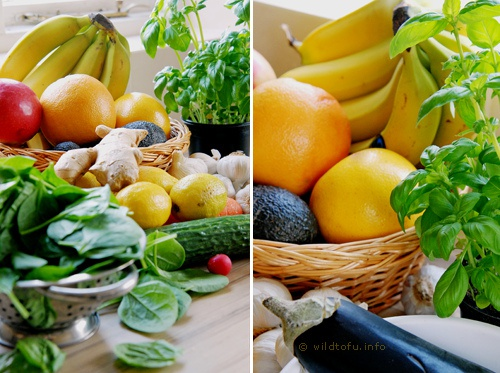Describe the objects in this image and their specific colors. I can see banana in lightgray, olive, and orange tones, bowl in lightgray, brown, maroon, and tan tones, orange in lightgray and orange tones, orange in lightgray, orange, khaki, and tan tones, and banana in lightgray, olive, and gold tones in this image. 